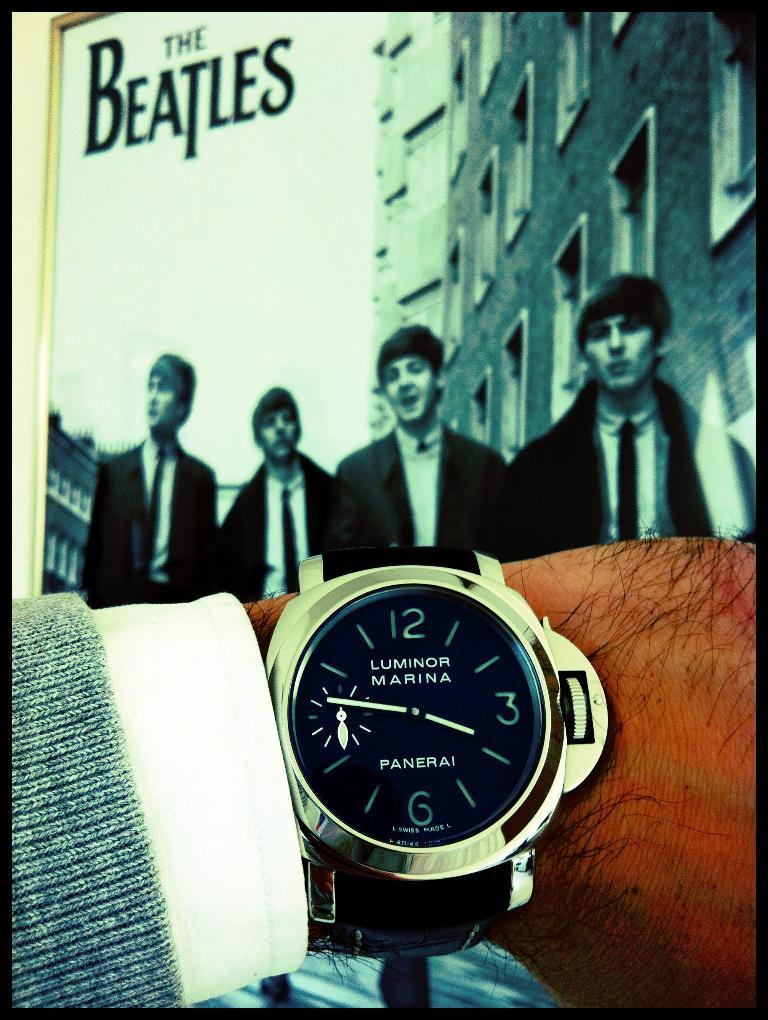<image>
Create a compact narrative representing the image presented. Four men standing together as a man looks at his Luminor Marina watch. 